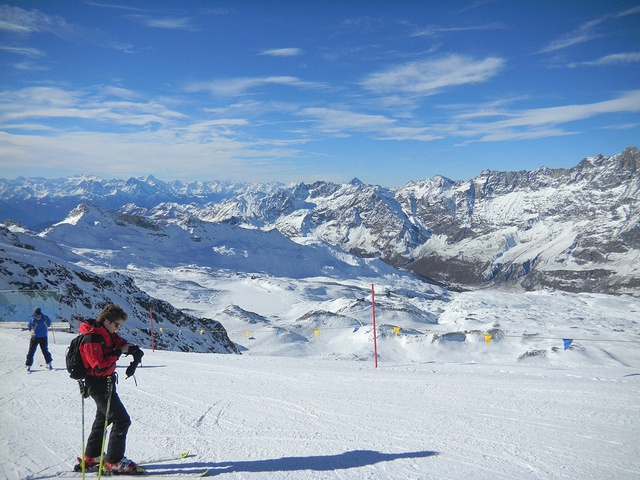Describe the objects in this image and their specific colors. I can see people in blue, black, maroon, gray, and lightgray tones, skis in blue, lightgray, darkgray, and gray tones, people in blue, navy, black, and gray tones, backpack in blue, black, gray, and maroon tones, and skis in blue, lightgray, darkgray, and gray tones in this image. 